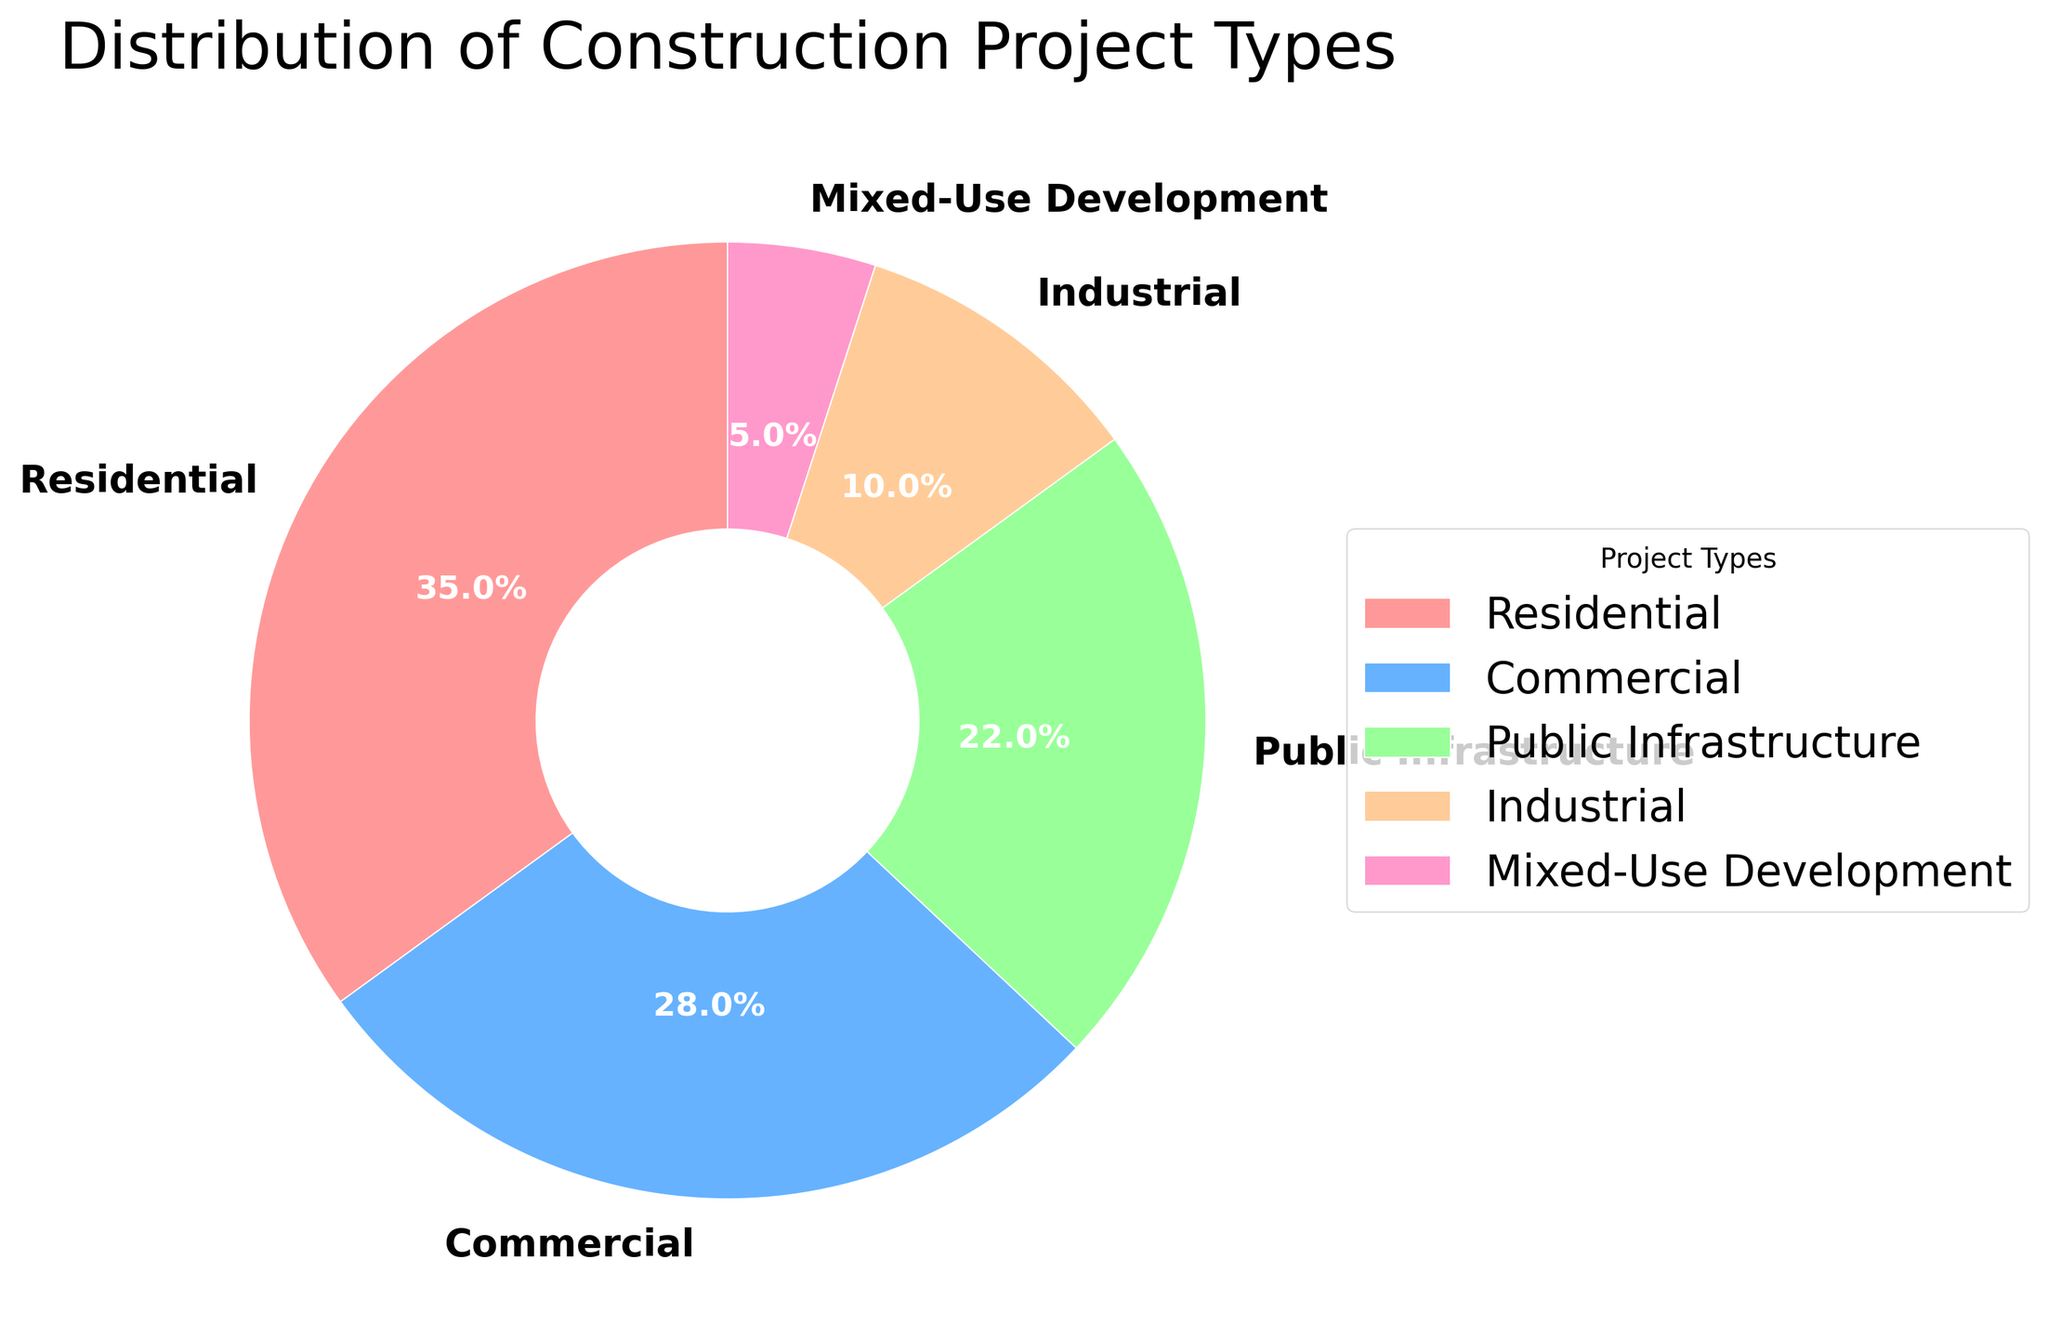What percentage of the construction projects are residential? To find the percentage of residential construction projects, refer to the pie chart section labeled "Residential." The percentage is clearly marked on the chart.
Answer: 35% Which project type has the smallest percentage? Compare all the sections of the pie chart and identify the one with the smallest percentage figure. The smallest section is indicated.
Answer: Mixed-Use Development How much larger is the percentage of commercial projects compared to industrial projects? Locate the percentages for both the commercial and industrial sections on the pie chart. Subtract the industrial percentage from the commercial percentage: 28% - 10% = 18%.
Answer: 18% What is the combined percentage of public infrastructure and industrial projects? Add the percentages of public infrastructure and industrial sections: 22% + 10% = 32%.
Answer: 32% Which project type is more common, residential or public infrastructure? Compare the residential and public infrastructure sections of the pie chart. The residential section has a higher percentage than the public infrastructure section (35% vs. 22%).
Answer: Residential Are there more commercial projects than public infrastructure projects? Compare the commercial and public infrastructure sections of the pie chart. The commercial section has 28%, which is more than the 22% of the public infrastructure section.
Answer: Yes What is the percentage difference between the largest and smallest project types? Identify the largest and smallest project percentages: residential (35%) and mixed-use development (5%). Subtract the smallest from the largest: 35% - 5% = 30%.
Answer: 30% What is the average percentage of the mixed-use development, public infrastructure, and industrial projects? Add the percentages of mixed-use development, public infrastructure, and industrial projects: 5% + 22% + 10% = 37%. Divide by the number of project types (3): 37% / 3 ≈ 12.33%.
Answer: 12.33% Which color represents the public infrastructure projects? Refer to the visual color key in the pie chart and match the color to the label "Public Infrastructure."
Answer: Orange Is the percentage of residential projects greater than the combined percentage of industrial and mixed-use development projects? Compare the residential percentage (35%) with the combined percentage of industrial (10%) and mixed-use development (5%): 10% + 5% = 15%. Since 35% > 15%, the answer is yes.
Answer: Yes 